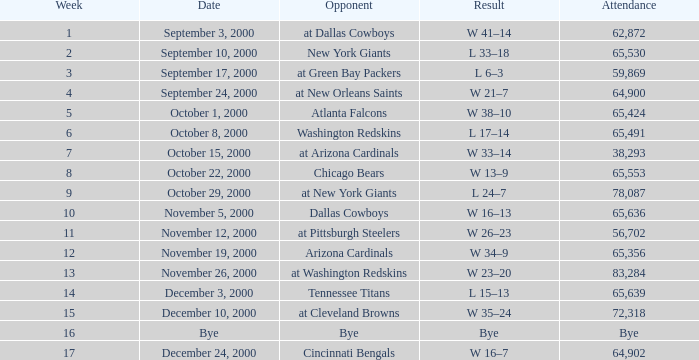What was the attendance when the Cincinnati Bengals were the opponents? 64902.0. 